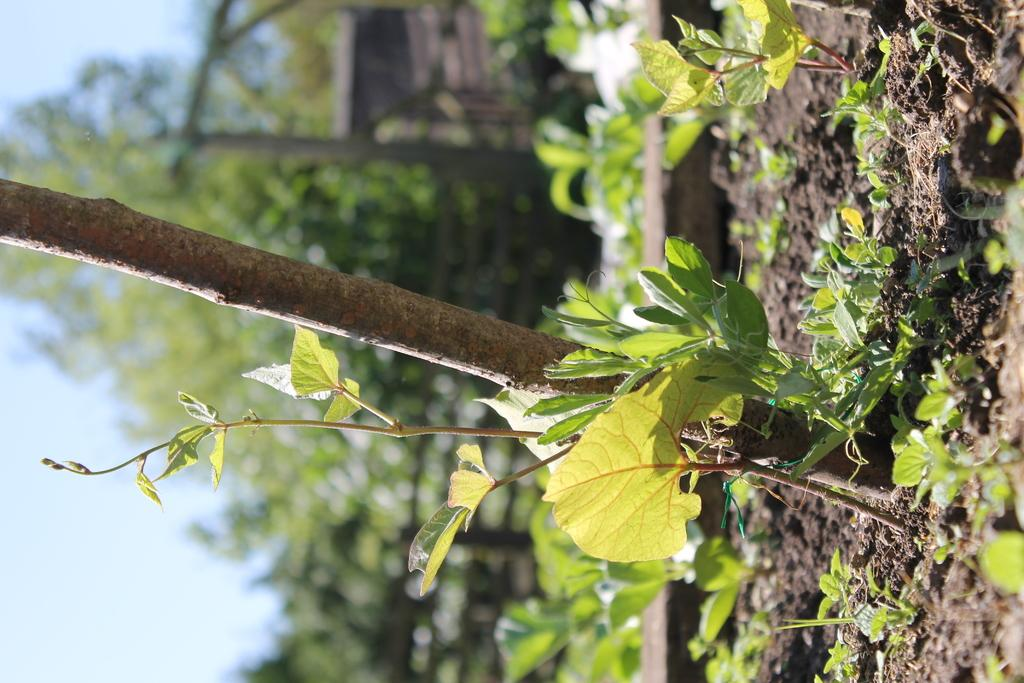What type of living organisms can be seen in the image? Plants and trees are visible in the image. Can you describe the natural setting visible in the image? The natural setting includes trees. What part of the sky is visible in the image? The sky is visible on the left side of the image. What type of collar can be seen on the plants in the image? There are no collars present on the plants in the image, as plants do not wear collars. 